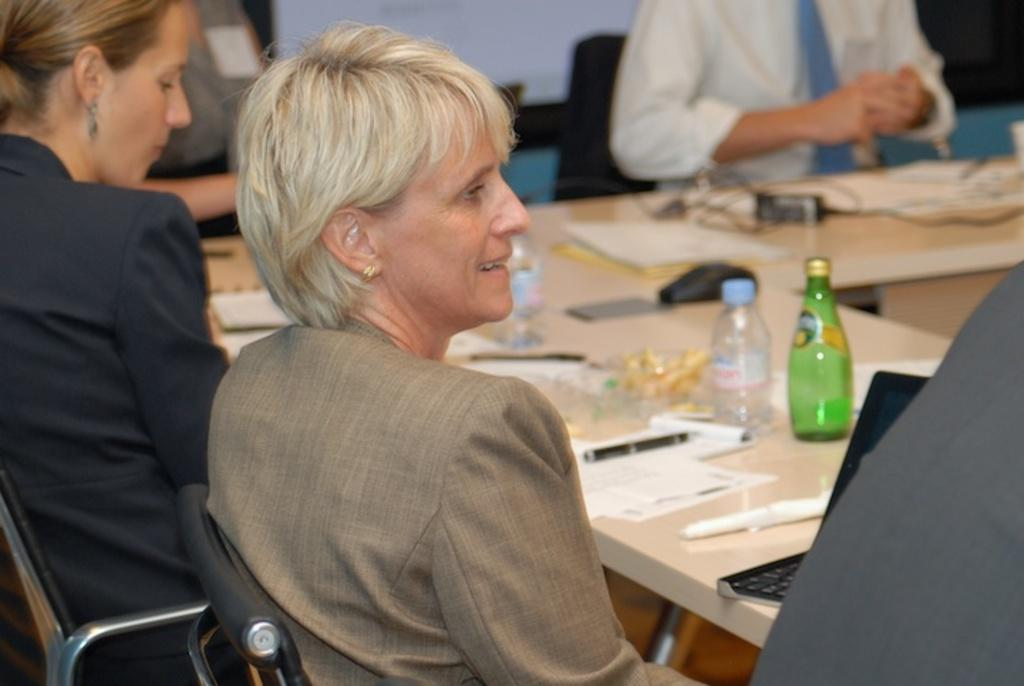What are the people in the image doing? The people in the image are sitting on chairs. How are the chairs arranged in relation to each other? The chairs are arranged around a table. What items can be seen on the table? There are papers, pens, and bottles on the table. What type of plant is growing on the table in the image? There is no plant growing on the table in the image. What type of plate is being used by the people in the image? There is no plate visible in the image. 